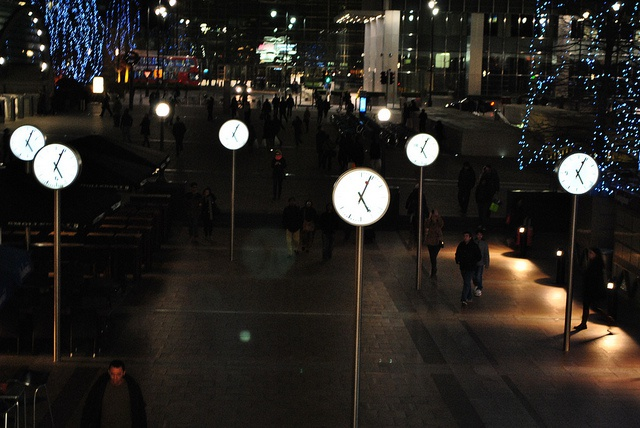Describe the objects in this image and their specific colors. I can see people in black, maroon, and gray tones, people in black, maroon, and brown tones, clock in black, white, tan, and darkgray tones, clock in black, white, gray, and darkgray tones, and clock in black, white, lightblue, and gray tones in this image. 